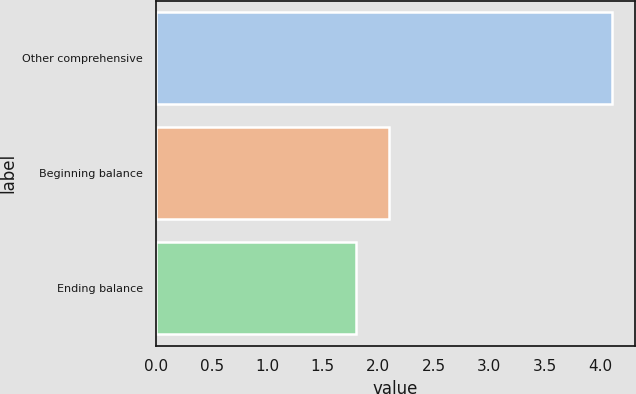<chart> <loc_0><loc_0><loc_500><loc_500><bar_chart><fcel>Other comprehensive<fcel>Beginning balance<fcel>Ending balance<nl><fcel>4.11<fcel>2.1<fcel>1.8<nl></chart> 